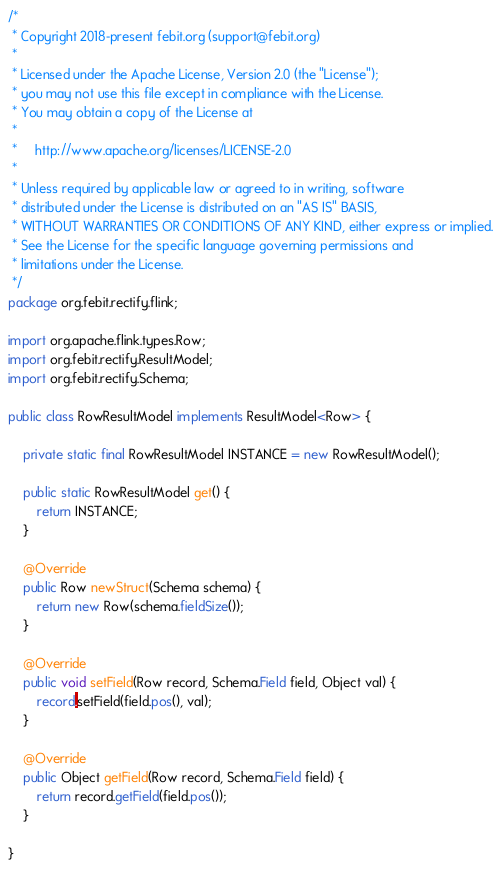<code> <loc_0><loc_0><loc_500><loc_500><_Java_>/*
 * Copyright 2018-present febit.org (support@febit.org)
 *
 * Licensed under the Apache License, Version 2.0 (the "License");
 * you may not use this file except in compliance with the License.
 * You may obtain a copy of the License at
 *
 *     http://www.apache.org/licenses/LICENSE-2.0
 *
 * Unless required by applicable law or agreed to in writing, software
 * distributed under the License is distributed on an "AS IS" BASIS,
 * WITHOUT WARRANTIES OR CONDITIONS OF ANY KIND, either express or implied.
 * See the License for the specific language governing permissions and
 * limitations under the License.
 */
package org.febit.rectify.flink;

import org.apache.flink.types.Row;
import org.febit.rectify.ResultModel;
import org.febit.rectify.Schema;

public class RowResultModel implements ResultModel<Row> {

    private static final RowResultModel INSTANCE = new RowResultModel();

    public static RowResultModel get() {
        return INSTANCE;
    }

    @Override
    public Row newStruct(Schema schema) {
        return new Row(schema.fieldSize());
    }

    @Override
    public void setField(Row record, Schema.Field field, Object val) {
        record.setField(field.pos(), val);
    }

    @Override
    public Object getField(Row record, Schema.Field field) {
        return record.getField(field.pos());
    }

}
</code> 